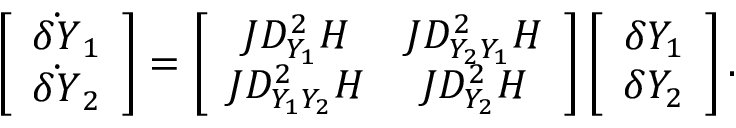Convert formula to latex. <formula><loc_0><loc_0><loc_500><loc_500>\left [ \begin{array} { c } { \dot { \delta Y } _ { 1 } } \\ { \dot { \delta Y } _ { 2 } } \end{array} \right ] = \left [ \begin{array} { c c } { J D _ { Y _ { 1 } } ^ { 2 } H } & { J D _ { Y _ { 2 } Y _ { 1 } } ^ { 2 } H } \\ { J D _ { Y _ { 1 } Y _ { 2 } } ^ { 2 } H } & { J D _ { Y _ { 2 } } ^ { 2 } H } \end{array} \right ] \left [ \begin{array} { c } { \delta Y _ { 1 } } \\ { \delta Y _ { 2 } } \end{array} \right ] .</formula> 